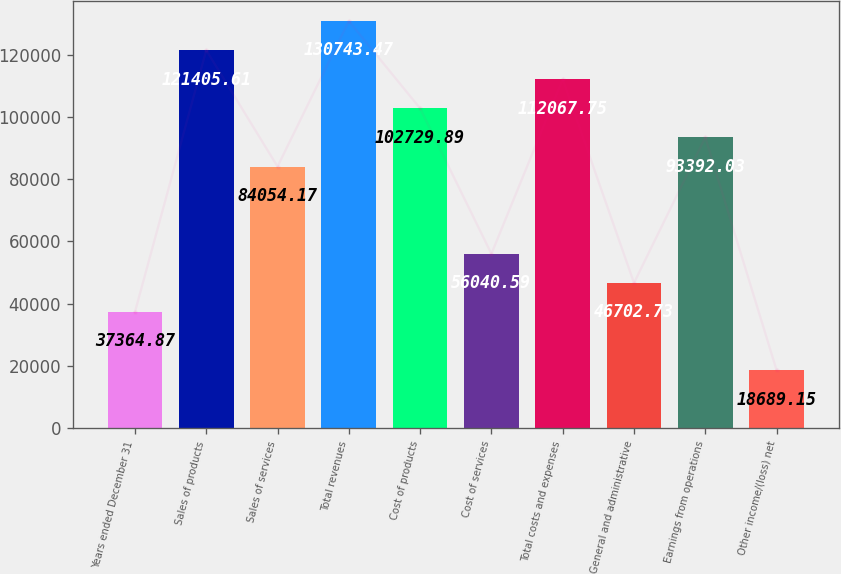Convert chart. <chart><loc_0><loc_0><loc_500><loc_500><bar_chart><fcel>Years ended December 31<fcel>Sales of products<fcel>Sales of services<fcel>Total revenues<fcel>Cost of products<fcel>Cost of services<fcel>Total costs and expenses<fcel>General and administrative<fcel>Earnings from operations<fcel>Other income/(loss) net<nl><fcel>37364.9<fcel>121406<fcel>84054.2<fcel>130743<fcel>102730<fcel>56040.6<fcel>112068<fcel>46702.7<fcel>93392<fcel>18689.2<nl></chart> 